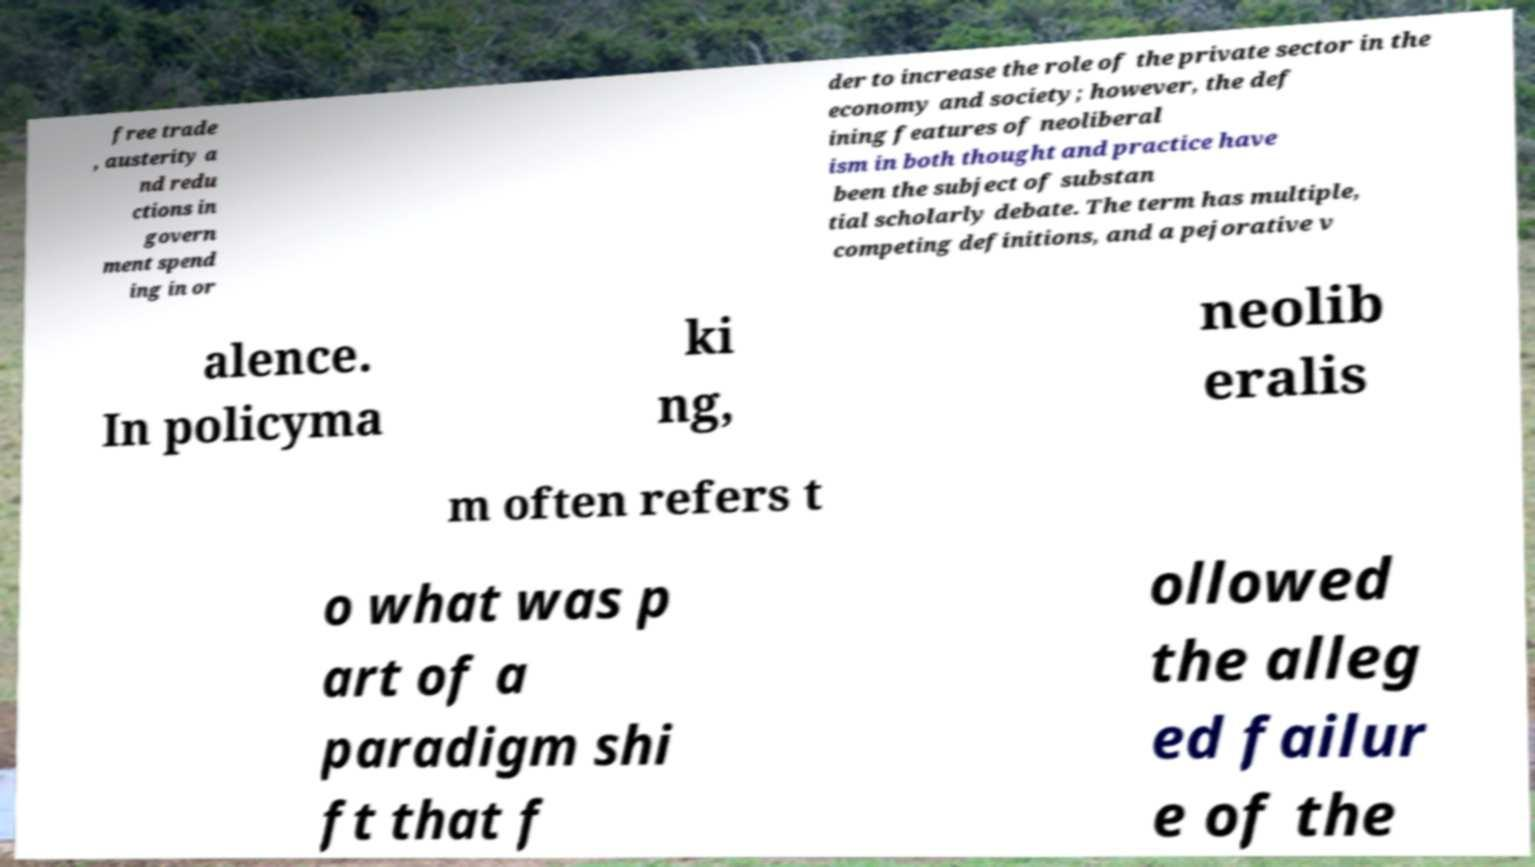There's text embedded in this image that I need extracted. Can you transcribe it verbatim? free trade , austerity a nd redu ctions in govern ment spend ing in or der to increase the role of the private sector in the economy and society; however, the def ining features of neoliberal ism in both thought and practice have been the subject of substan tial scholarly debate. The term has multiple, competing definitions, and a pejorative v alence. In policyma ki ng, neolib eralis m often refers t o what was p art of a paradigm shi ft that f ollowed the alleg ed failur e of the 